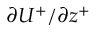<formula> <loc_0><loc_0><loc_500><loc_500>{ { \partial } U ^ { + } } / { { \partial } z ^ { + } }</formula> 